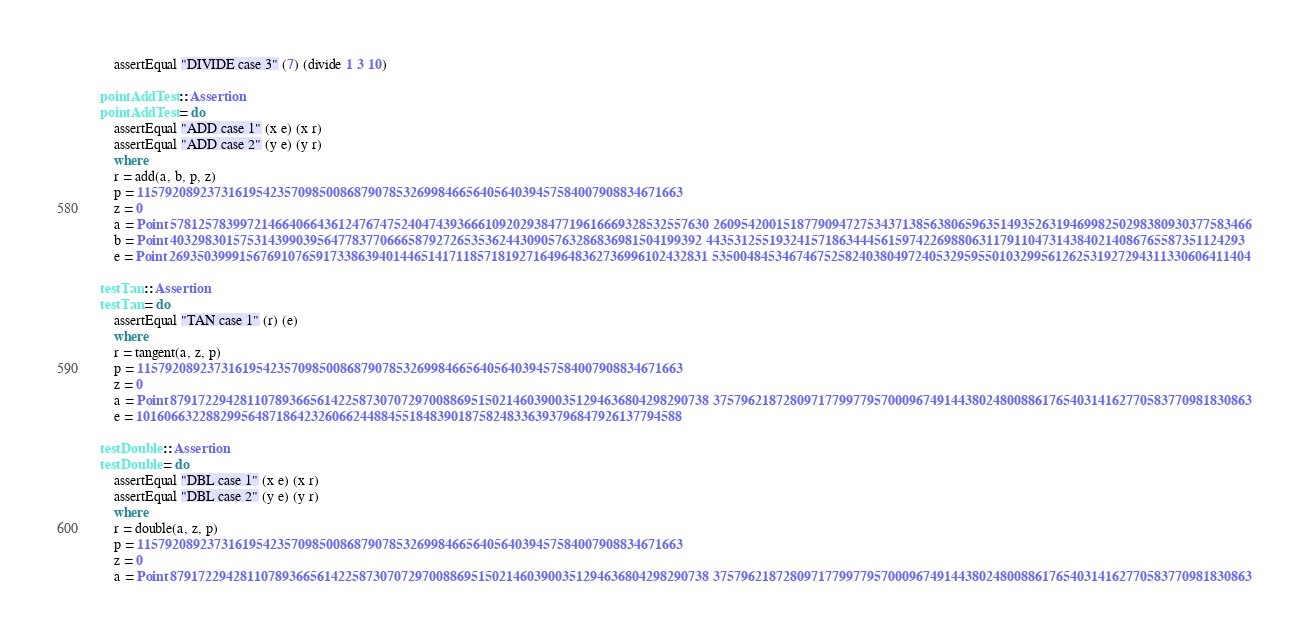Convert code to text. <code><loc_0><loc_0><loc_500><loc_500><_Haskell_>    assertEqual "DIVIDE case 3" (7) (divide 1 3 10)

pointAddTest :: Assertion
pointAddTest = do
    assertEqual "ADD case 1" (x e) (x r)
    assertEqual "ADD case 2" (y e) (y r)
    where
    r = add(a, b, p, z)
    p = 115792089237316195423570985008687907853269984665640564039457584007908834671663
    z = 0
    a = Point 57812578399721466406643612476747524047439366610920293847719616669328532557630 26095420015187790947275343713856380659635149352631946998250298380930377583466
    b = Point 4032983015753143990395647783770666587927265353624430905763286836981504199392 44353125519324157186344456159742269880631179110473143840214086765587351124293
    e = Point 26935039991567691076591733863940144651417118571819271649648362736996102432831 53500484534674675258240380497240532959550103299561262531927294311330606411404

testTan :: Assertion
testTan = do
    assertEqual "TAN case 1" (r) (e)
    where
    r = tangent(a, z, p)
    p = 115792089237316195423570985008687907853269984665640564039457584007908834671663
    z = 0
    a = Point 87917229428110789366561422587307072970088695150214603900351294636804298290738 37579621872809717799779570009674914438024800886176540314162770583770981830863
    e = 101606632288299564871864232606624488455184839018758248336393796847926137794588

testDouble :: Assertion
testDouble = do
    assertEqual "DBL case 1" (x e) (x r)
    assertEqual "DBL case 2" (y e) (y r)
    where
    r = double(a, z, p)
    p = 115792089237316195423570985008687907853269984665640564039457584007908834671663
    z = 0
    a = Point 87917229428110789366561422587307072970088695150214603900351294636804298290738 37579621872809717799779570009674914438024800886176540314162770583770981830863</code> 